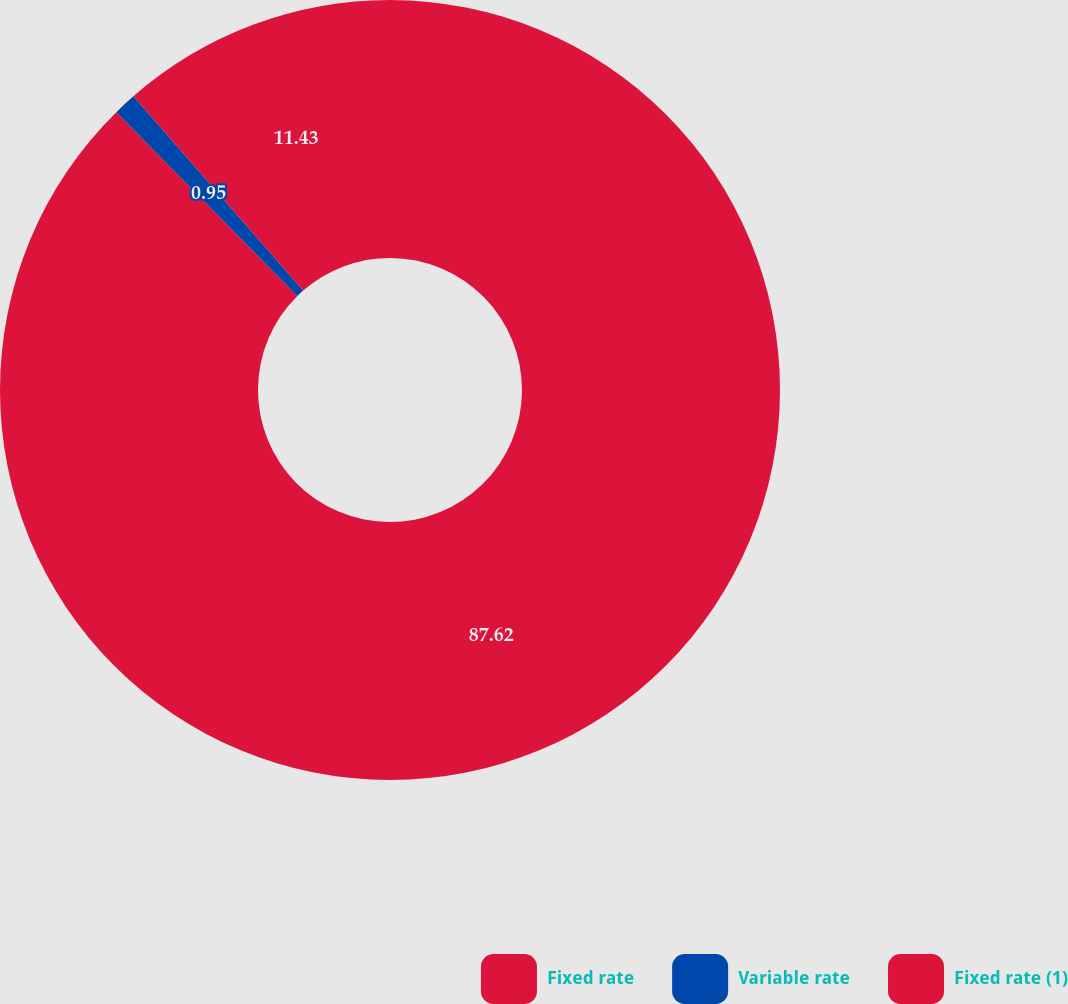<chart> <loc_0><loc_0><loc_500><loc_500><pie_chart><fcel>Fixed rate<fcel>Variable rate<fcel>Fixed rate (1)<nl><fcel>87.62%<fcel>0.95%<fcel>11.43%<nl></chart> 